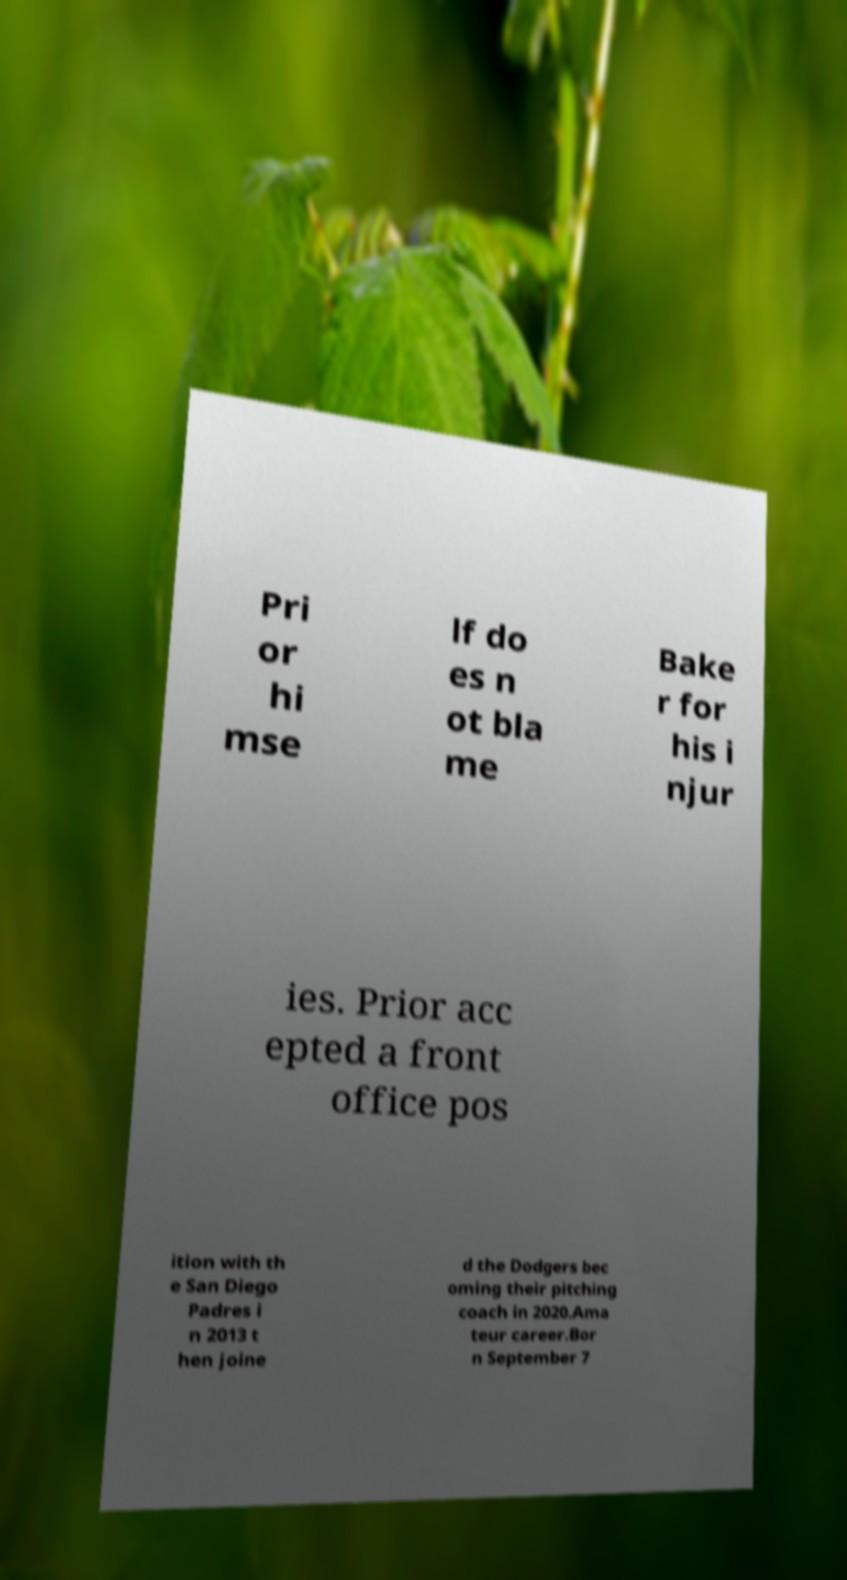Can you read and provide the text displayed in the image?This photo seems to have some interesting text. Can you extract and type it out for me? Pri or hi mse lf do es n ot bla me Bake r for his i njur ies. Prior acc epted a front office pos ition with th e San Diego Padres i n 2013 t hen joine d the Dodgers bec oming their pitching coach in 2020.Ama teur career.Bor n September 7 